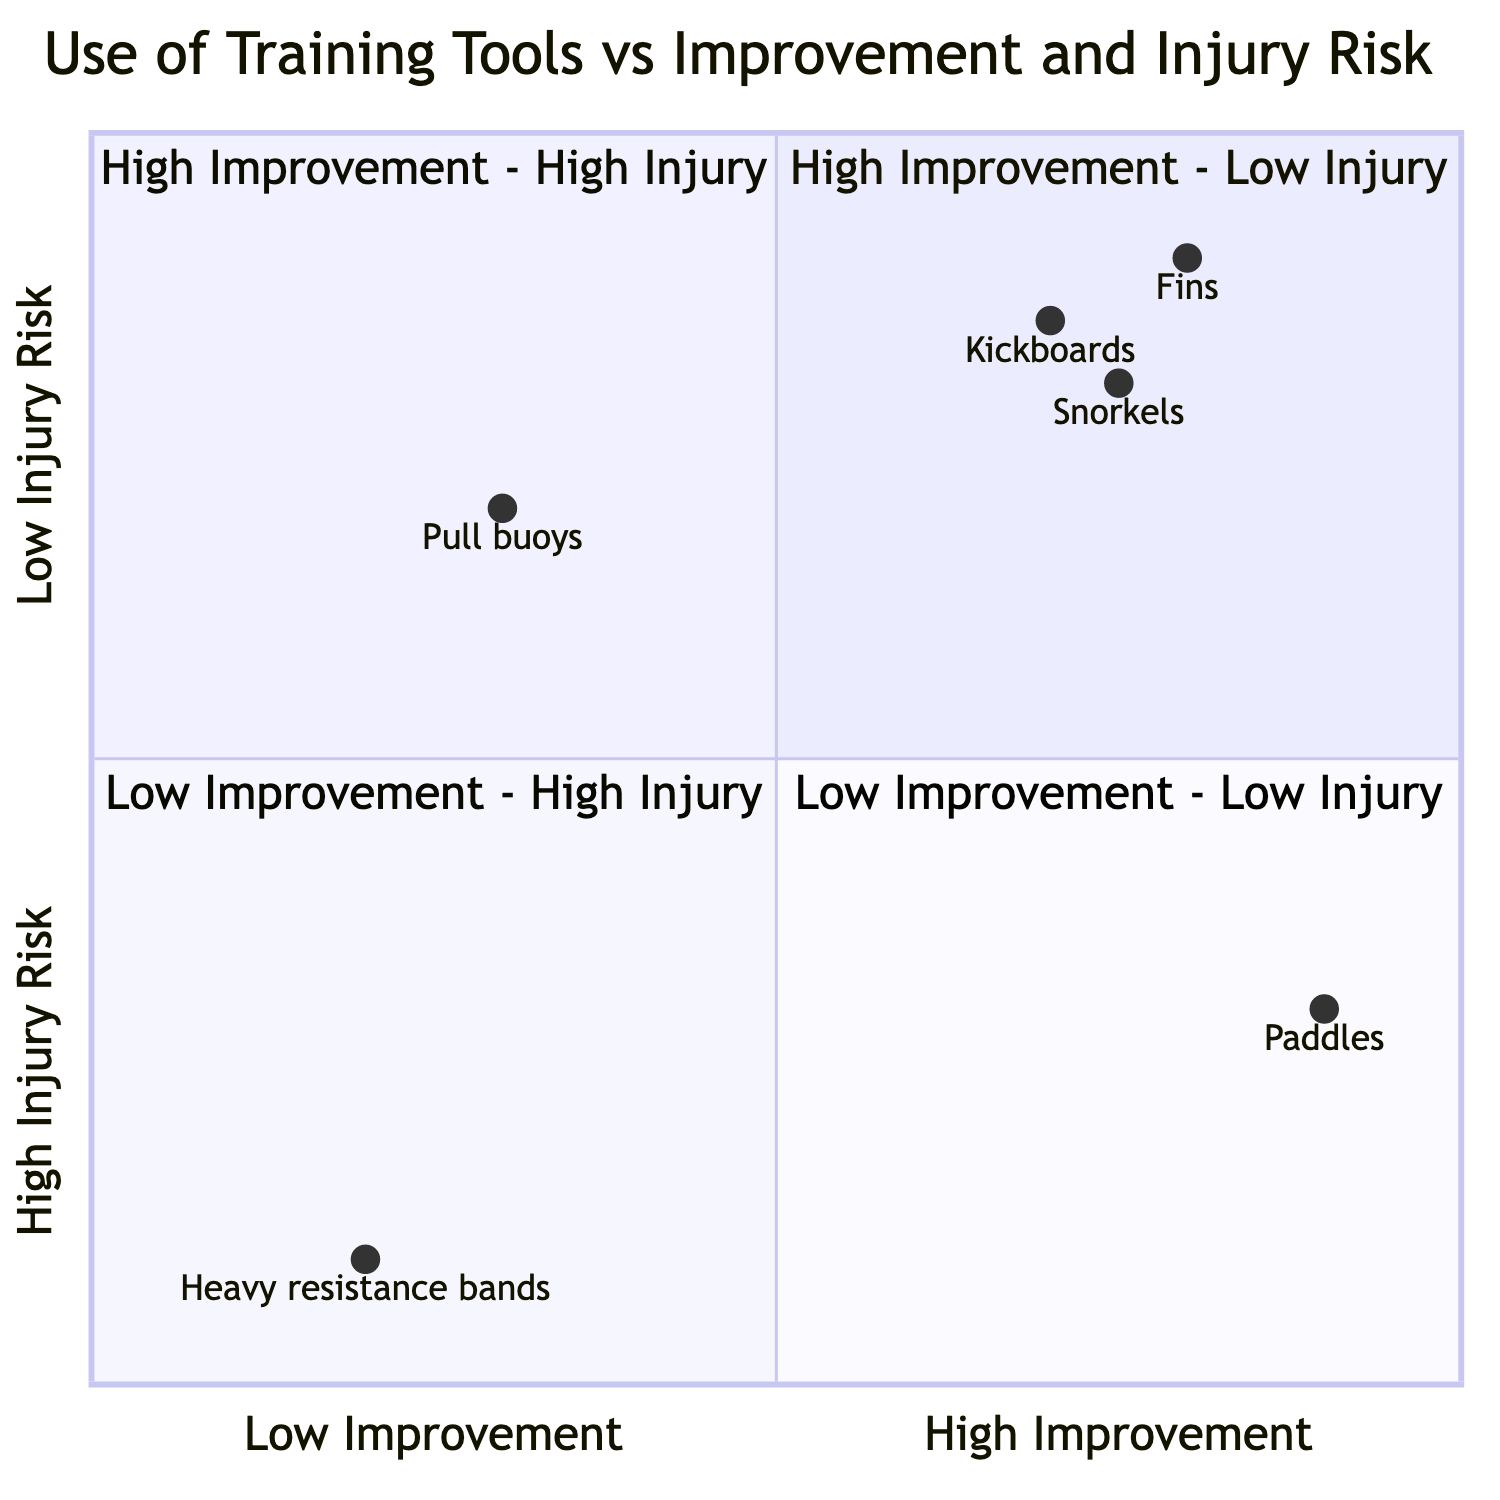What training tool is in the "High Improvement - Low Injury" quadrant? The tools listed in the "High Improvement - Low Injury" quadrant are Fins, Kickboards, and Snorkels.
Answer: Fins Which tool shows the lowest improvement in swim speed? The tool with the lowest improvement in swim speed is Heavy resistance bands, located in the "Low Improvement - High Injury" quadrant.
Answer: Heavy resistance bands How many training tools are categorized as "High Improvement - High Injury"? There is one training tool, which is Paddles, categorized in the "High Improvement - High Injury" quadrant.
Answer: One Which tool provides moderate upper body improvement with low injury risk? The tool that provides moderate upper body improvement with low injury risk is Pull buoys, found in the "Low Improvement - Low Injury" quadrant.
Answer: Pull buoys What is the coaching feedback for the use of Paddles? The coaching feedback states that Paddles should be used with caution and under guidance to prevent overloading shoulders.
Answer: Use with caution Which training tool is recommended for enhancing kicking technique? Kickboards are recommended for enhancing kicking technique, positioned in the "High Improvement - Low Injury" quadrant.
Answer: Kickboards What is the relationship between Heavy resistance bands and swim speed improvement? Heavy resistance bands lead to minimal improvement in swim speed and are categorized in the "Low Improvement - High Injury" quadrant.
Answer: Minimal improvement What is the risk level associated with Snorkels? Snorkels are associated with low injury risk, as they are in the "High Improvement - Low Injury" quadrant.
Answer: Low injury risk 